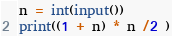Convert code to text. <code><loc_0><loc_0><loc_500><loc_500><_Python_>n = int(input())
print((1 + n) * n /2 )</code> 